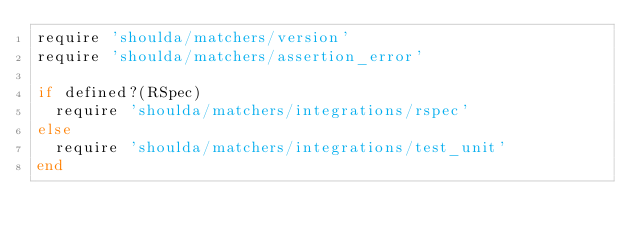<code> <loc_0><loc_0><loc_500><loc_500><_Ruby_>require 'shoulda/matchers/version'
require 'shoulda/matchers/assertion_error'

if defined?(RSpec)
  require 'shoulda/matchers/integrations/rspec'
else
  require 'shoulda/matchers/integrations/test_unit'
end
</code> 